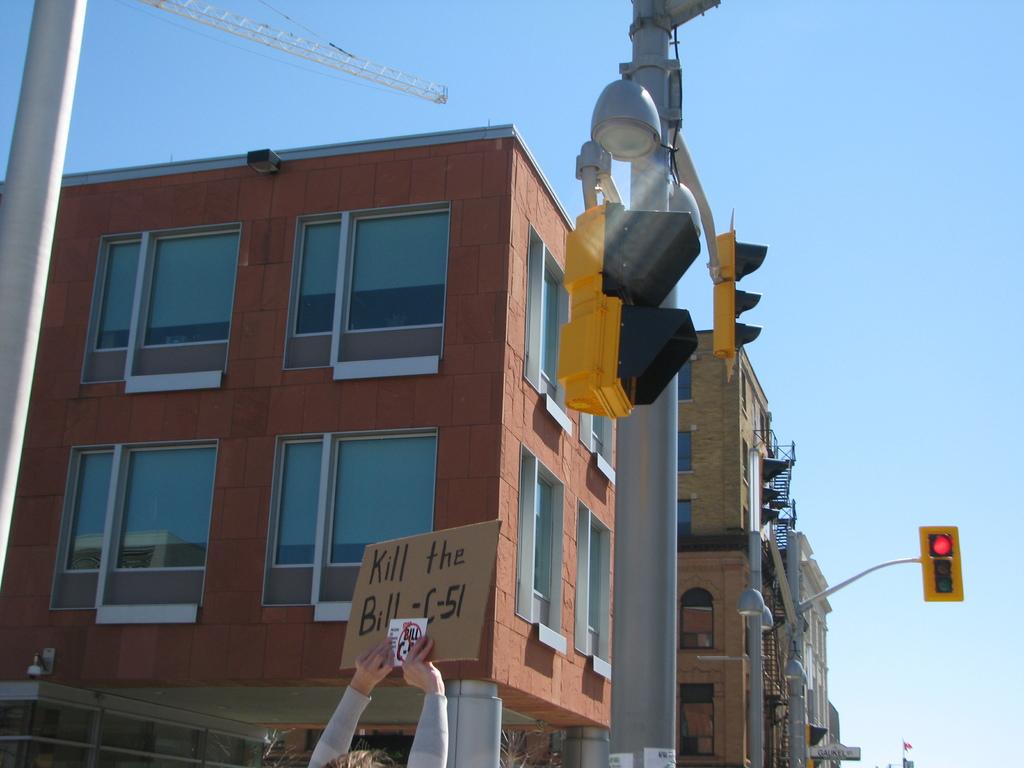Which bill does the protester want killed?
Offer a very short reply. C-51. 